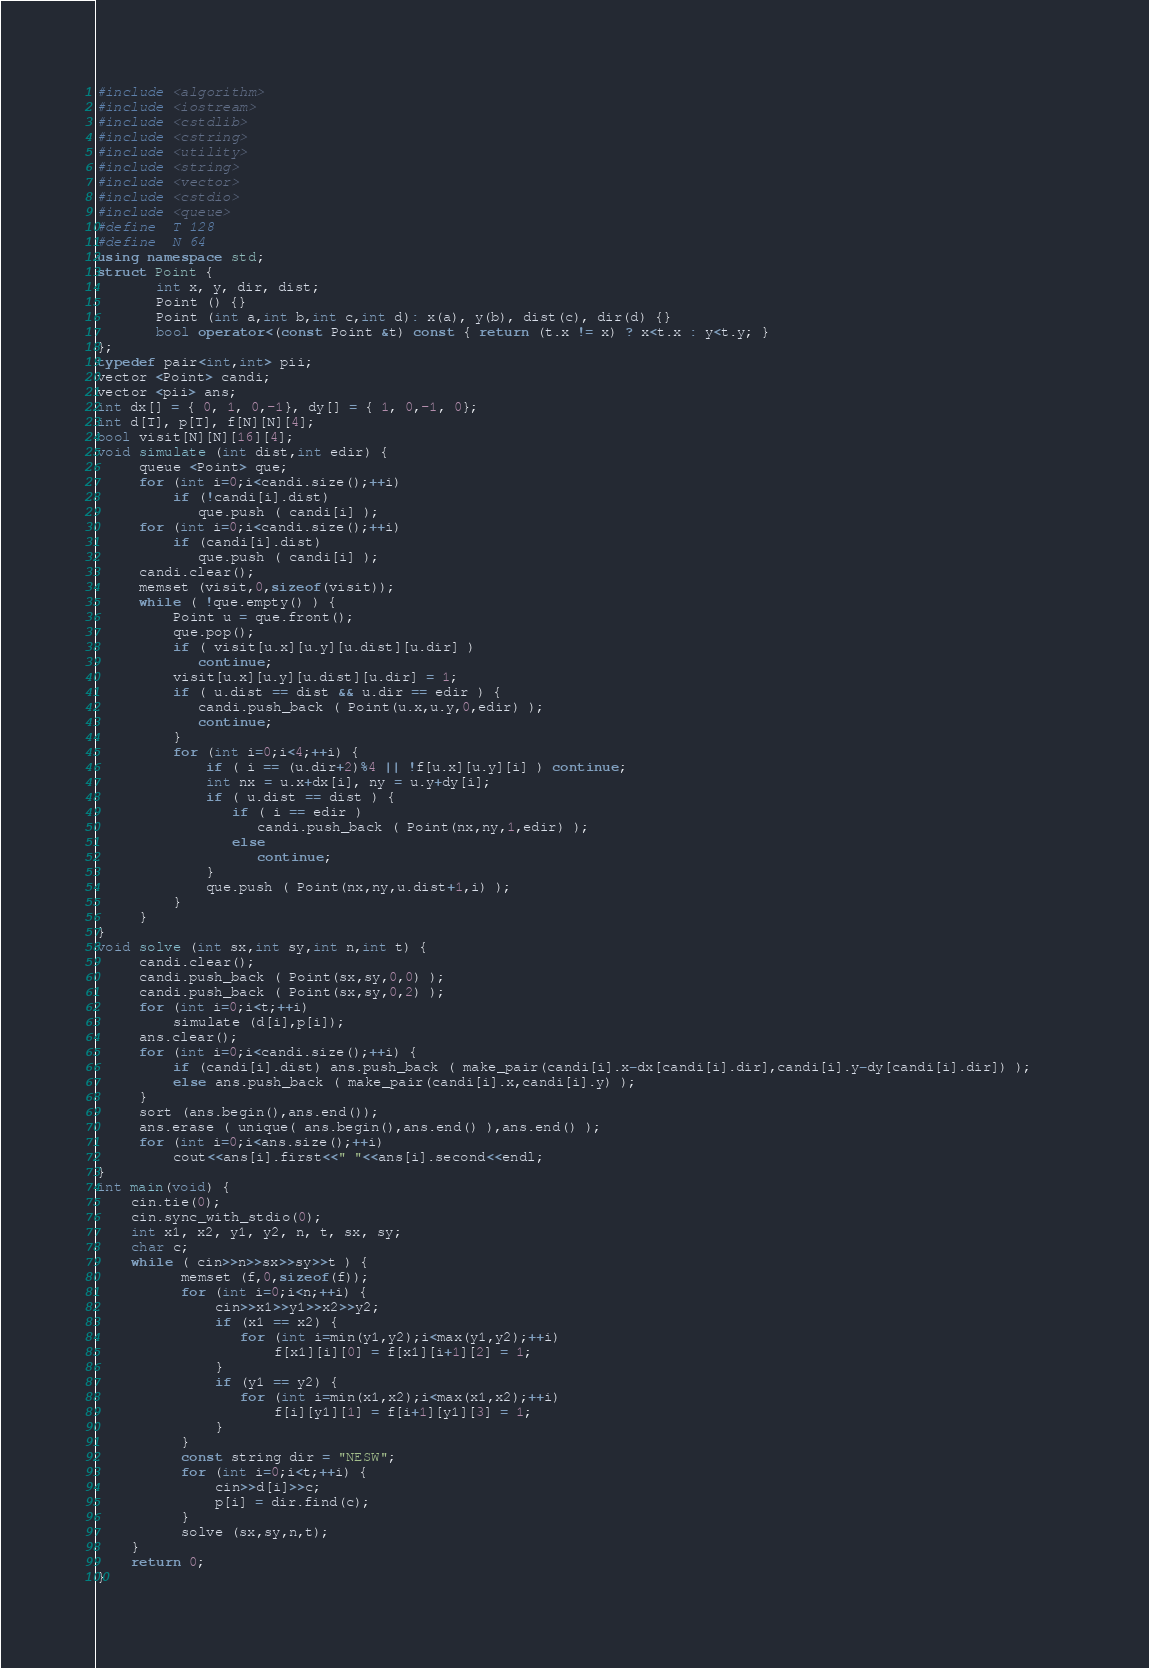<code> <loc_0><loc_0><loc_500><loc_500><_C++_>#include <algorithm>
#include <iostream>
#include <cstdlib>
#include <cstring>
#include <utility>
#include <string>
#include <vector>
#include <cstdio>
#include <queue>
#define  T 128
#define  N 64
using namespace std;
struct Point {
       int x, y, dir, dist;     
       Point () {}
       Point (int a,int b,int c,int d): x(a), y(b), dist(c), dir(d) {}
       bool operator<(const Point &t) const { return (t.x != x) ? x<t.x : y<t.y; }
};
typedef pair<int,int> pii;
vector <Point> candi;
vector <pii> ans;
int dx[] = { 0, 1, 0,-1}, dy[] = { 1, 0,-1, 0};
int d[T], p[T], f[N][N][4]; 
bool visit[N][N][16][4];
void simulate (int dist,int edir) {
     queue <Point> que;
     for (int i=0;i<candi.size();++i)
         if (!candi[i].dist)
            que.push ( candi[i] );
     for (int i=0;i<candi.size();++i)
         if (candi[i].dist)
            que.push ( candi[i] );
     candi.clear();
     memset (visit,0,sizeof(visit));
     while ( !que.empty() ) {
         Point u = que.front();
         que.pop();
         if ( visit[u.x][u.y][u.dist][u.dir] ) 
            continue;
         visit[u.x][u.y][u.dist][u.dir] = 1;
         if ( u.dist == dist && u.dir == edir ) {
            candi.push_back ( Point(u.x,u.y,0,edir) );
            continue;
         }
         for (int i=0;i<4;++i) {
             if ( i == (u.dir+2)%4 || !f[u.x][u.y][i] ) continue;
             int nx = u.x+dx[i], ny = u.y+dy[i];
             if ( u.dist == dist ) {  
                if ( i == edir )
                   candi.push_back ( Point(nx,ny,1,edir) );
                else   
                   continue;  
             }
             que.push ( Point(nx,ny,u.dist+1,i) );
         }
     }
}
void solve (int sx,int sy,int n,int t) {
     candi.clear();
     candi.push_back ( Point(sx,sy,0,0) );
     candi.push_back ( Point(sx,sy,0,2) );
     for (int i=0;i<t;++i)
         simulate (d[i],p[i]);
     ans.clear();
     for (int i=0;i<candi.size();++i) {
         if (candi[i].dist) ans.push_back ( make_pair(candi[i].x-dx[candi[i].dir],candi[i].y-dy[candi[i].dir]) );    
         else ans.push_back ( make_pair(candi[i].x,candi[i].y) );
     }
     sort (ans.begin(),ans.end());
     ans.erase ( unique( ans.begin(),ans.end() ),ans.end() );
     for (int i=0;i<ans.size();++i)
         cout<<ans[i].first<<" "<<ans[i].second<<endl;    
}
int main(void) {
    cin.tie(0);
    cin.sync_with_stdio(0);
    int x1, x2, y1, y2, n, t, sx, sy;
    char c;
    while ( cin>>n>>sx>>sy>>t ) {
          memset (f,0,sizeof(f));
          for (int i=0;i<n;++i) {
              cin>>x1>>y1>>x2>>y2;
              if (x1 == x2) {
                 for (int i=min(y1,y2);i<max(y1,y2);++i)
                     f[x1][i][0] = f[x1][i+1][2] = 1;
              }
              if (y1 == y2) {
                 for (int i=min(x1,x2);i<max(x1,x2);++i)
                     f[i][y1][1] = f[i+1][y1][3] = 1;       
              }
          }
          const string dir = "NESW";
          for (int i=0;i<t;++i) {
              cin>>d[i]>>c;
              p[i] = dir.find(c);
          }
          solve (sx,sy,n,t);          
    }
    return 0;    
}</code> 